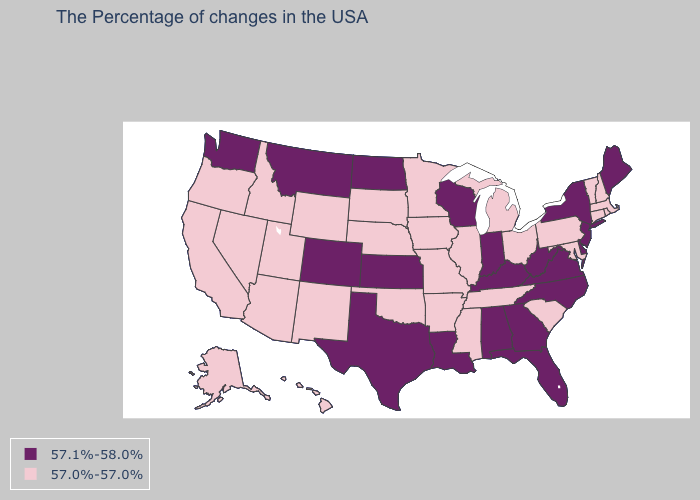Name the states that have a value in the range 57.1%-58.0%?
Concise answer only. Maine, New York, New Jersey, Delaware, Virginia, North Carolina, West Virginia, Florida, Georgia, Kentucky, Indiana, Alabama, Wisconsin, Louisiana, Kansas, Texas, North Dakota, Colorado, Montana, Washington. Does Washington have the highest value in the West?
Be succinct. Yes. Name the states that have a value in the range 57.0%-57.0%?
Quick response, please. Massachusetts, Rhode Island, New Hampshire, Vermont, Connecticut, Maryland, Pennsylvania, South Carolina, Ohio, Michigan, Tennessee, Illinois, Mississippi, Missouri, Arkansas, Minnesota, Iowa, Nebraska, Oklahoma, South Dakota, Wyoming, New Mexico, Utah, Arizona, Idaho, Nevada, California, Oregon, Alaska, Hawaii. Among the states that border New Jersey , does Pennsylvania have the highest value?
Be succinct. No. Name the states that have a value in the range 57.1%-58.0%?
Concise answer only. Maine, New York, New Jersey, Delaware, Virginia, North Carolina, West Virginia, Florida, Georgia, Kentucky, Indiana, Alabama, Wisconsin, Louisiana, Kansas, Texas, North Dakota, Colorado, Montana, Washington. Name the states that have a value in the range 57.1%-58.0%?
Quick response, please. Maine, New York, New Jersey, Delaware, Virginia, North Carolina, West Virginia, Florida, Georgia, Kentucky, Indiana, Alabama, Wisconsin, Louisiana, Kansas, Texas, North Dakota, Colorado, Montana, Washington. Is the legend a continuous bar?
Answer briefly. No. Which states have the lowest value in the Northeast?
Quick response, please. Massachusetts, Rhode Island, New Hampshire, Vermont, Connecticut, Pennsylvania. Does New York have the highest value in the USA?
Give a very brief answer. Yes. Name the states that have a value in the range 57.1%-58.0%?
Quick response, please. Maine, New York, New Jersey, Delaware, Virginia, North Carolina, West Virginia, Florida, Georgia, Kentucky, Indiana, Alabama, Wisconsin, Louisiana, Kansas, Texas, North Dakota, Colorado, Montana, Washington. Name the states that have a value in the range 57.0%-57.0%?
Short answer required. Massachusetts, Rhode Island, New Hampshire, Vermont, Connecticut, Maryland, Pennsylvania, South Carolina, Ohio, Michigan, Tennessee, Illinois, Mississippi, Missouri, Arkansas, Minnesota, Iowa, Nebraska, Oklahoma, South Dakota, Wyoming, New Mexico, Utah, Arizona, Idaho, Nevada, California, Oregon, Alaska, Hawaii. Which states have the lowest value in the West?
Short answer required. Wyoming, New Mexico, Utah, Arizona, Idaho, Nevada, California, Oregon, Alaska, Hawaii. What is the value of Virginia?
Be succinct. 57.1%-58.0%. What is the value of Rhode Island?
Give a very brief answer. 57.0%-57.0%. What is the value of North Dakota?
Concise answer only. 57.1%-58.0%. 